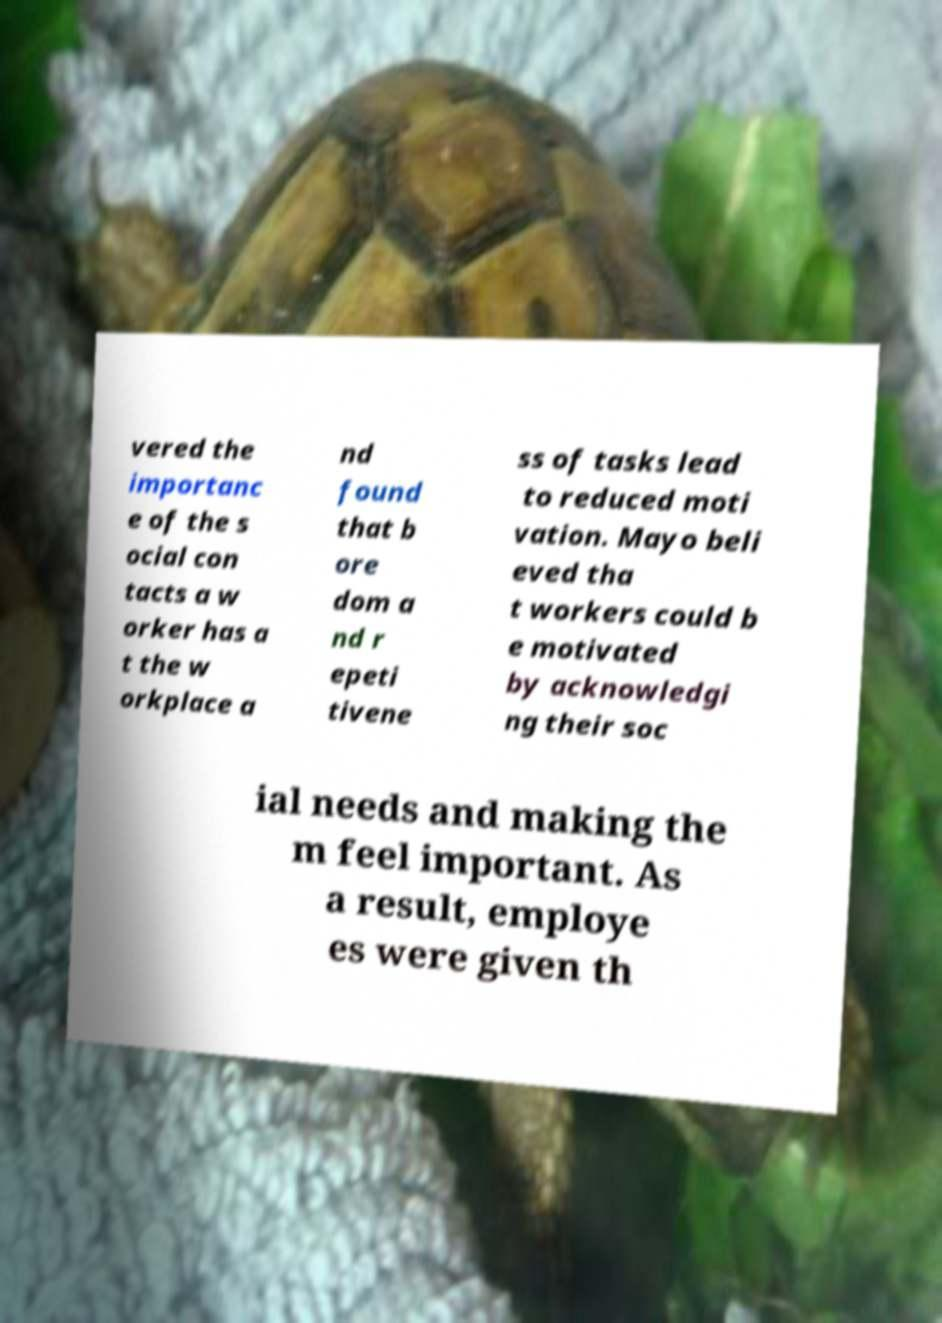Could you assist in decoding the text presented in this image and type it out clearly? vered the importanc e of the s ocial con tacts a w orker has a t the w orkplace a nd found that b ore dom a nd r epeti tivene ss of tasks lead to reduced moti vation. Mayo beli eved tha t workers could b e motivated by acknowledgi ng their soc ial needs and making the m feel important. As a result, employe es were given th 